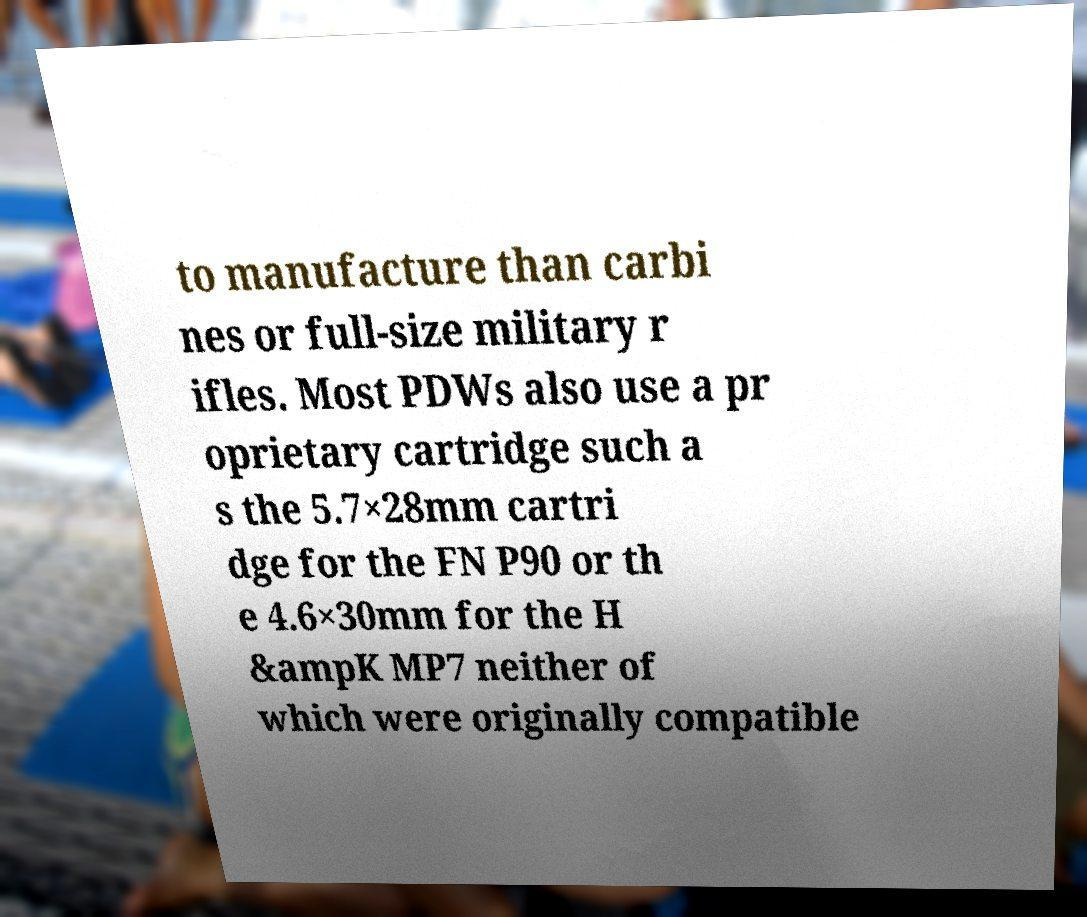There's text embedded in this image that I need extracted. Can you transcribe it verbatim? to manufacture than carbi nes or full-size military r ifles. Most PDWs also use a pr oprietary cartridge such a s the 5.7×28mm cartri dge for the FN P90 or th e 4.6×30mm for the H &ampK MP7 neither of which were originally compatible 